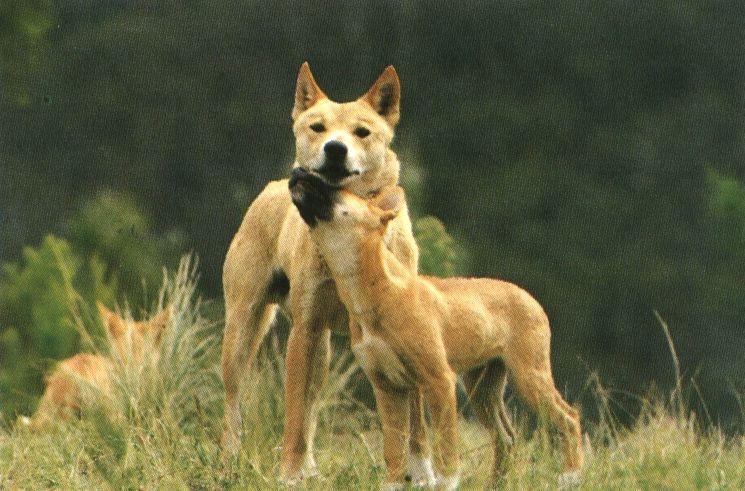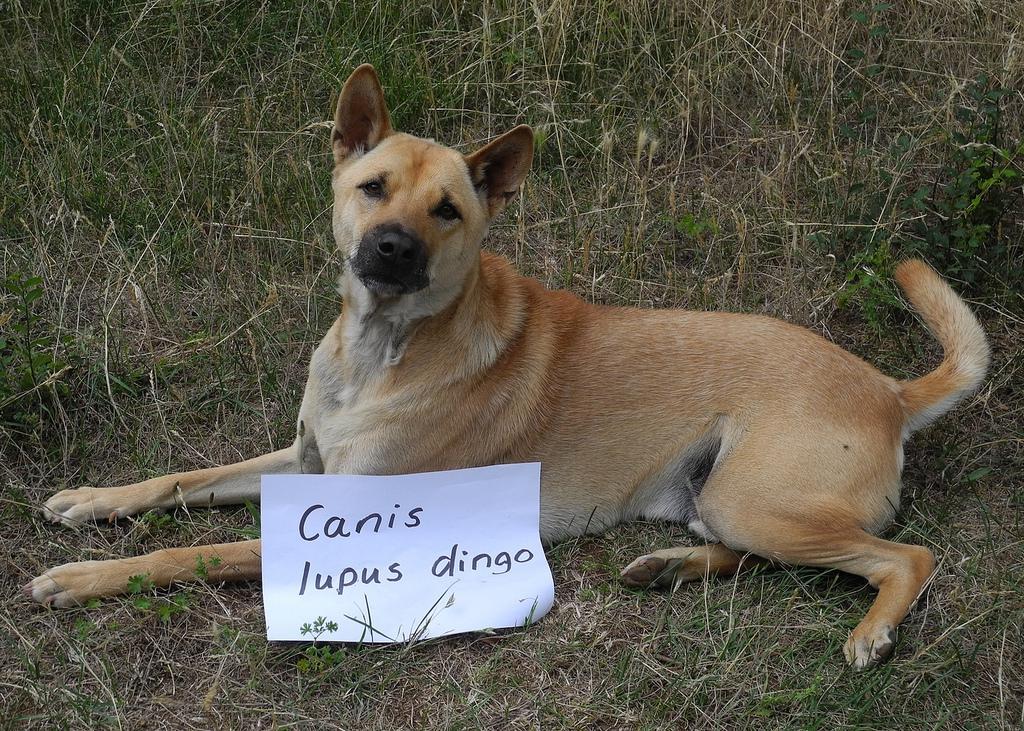The first image is the image on the left, the second image is the image on the right. For the images displayed, is the sentence "There is a tan and white canine laying in the dirt and grass." factually correct? Answer yes or no. Yes. 